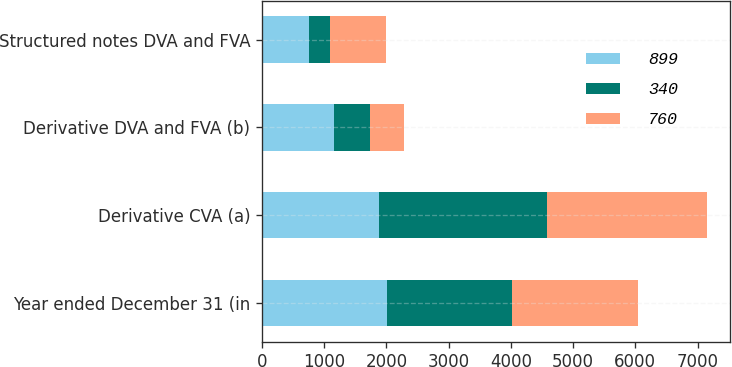Convert chart. <chart><loc_0><loc_0><loc_500><loc_500><stacked_bar_chart><ecel><fcel>Year ended December 31 (in<fcel>Derivative CVA (a)<fcel>Derivative DVA and FVA (b)<fcel>Structured notes DVA and FVA<nl><fcel>899<fcel>2013<fcel>1886<fcel>1152<fcel>760<nl><fcel>340<fcel>2012<fcel>2698<fcel>590<fcel>340<nl><fcel>760<fcel>2011<fcel>2574<fcel>538<fcel>899<nl></chart> 